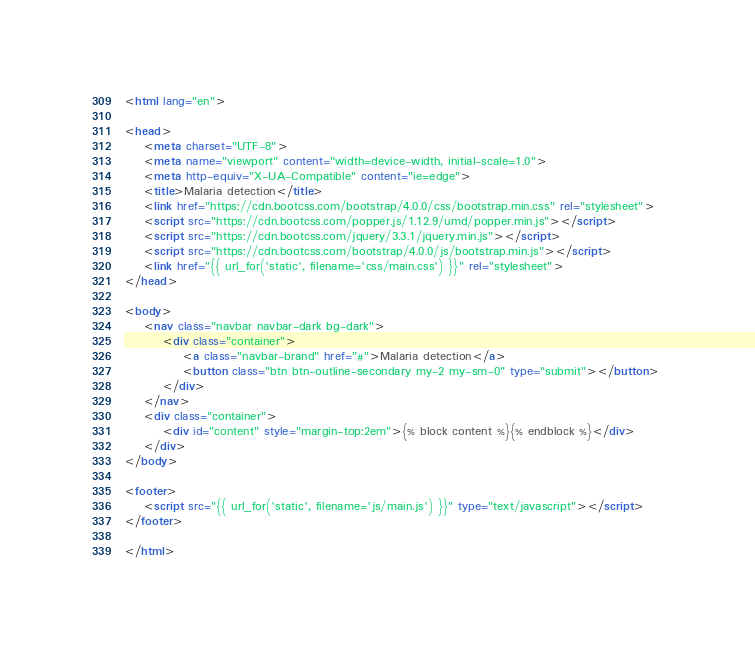<code> <loc_0><loc_0><loc_500><loc_500><_HTML_><html lang="en">

<head>
    <meta charset="UTF-8">
    <meta name="viewport" content="width=device-width, initial-scale=1.0">
    <meta http-equiv="X-UA-Compatible" content="ie=edge">
    <title>Malaria detection</title>
    <link href="https://cdn.bootcss.com/bootstrap/4.0.0/css/bootstrap.min.css" rel="stylesheet">
    <script src="https://cdn.bootcss.com/popper.js/1.12.9/umd/popper.min.js"></script>
    <script src="https://cdn.bootcss.com/jquery/3.3.1/jquery.min.js"></script>
    <script src="https://cdn.bootcss.com/bootstrap/4.0.0/js/bootstrap.min.js"></script>
    <link href="{{ url_for('static', filename='css/main.css') }}" rel="stylesheet">      
</head>

<body>
    <nav class="navbar navbar-dark bg-dark">
        <div class="container">
            <a class="navbar-brand" href="#">Malaria detection</a>
            <button class="btn btn-outline-secondary my-2 my-sm-0" type="submit"></button>
        </div>
    </nav>
    <div class="container">
        <div id="content" style="margin-top:2em">{% block content %}{% endblock %}</div>
    </div>
</body>

<footer>
    <script src="{{ url_for('static', filename='js/main.js') }}" type="text/javascript"></script>    
</footer>

</html>
</code> 